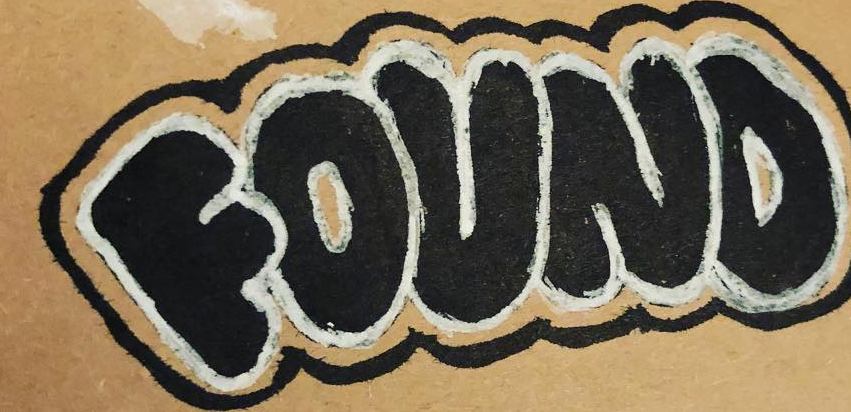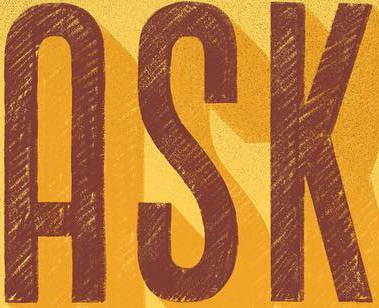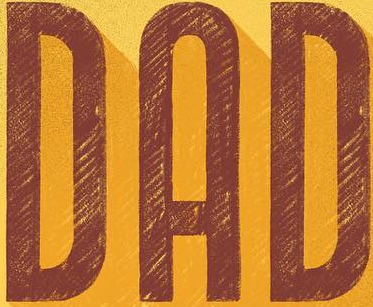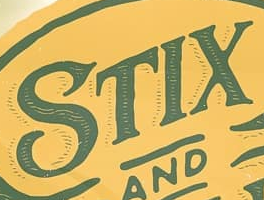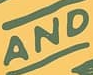Read the text content from these images in order, separated by a semicolon. FOUND; ASK; DAD; STIX; AND 